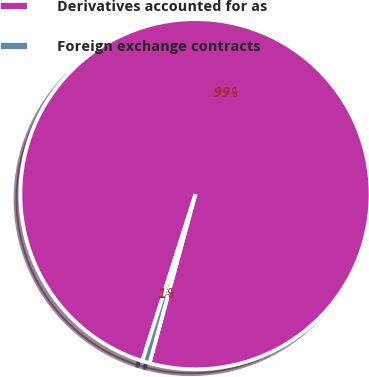<chart> <loc_0><loc_0><loc_500><loc_500><pie_chart><fcel>Derivatives accounted for as<fcel>Foreign exchange contracts<nl><fcel>99.31%<fcel>0.69%<nl></chart> 